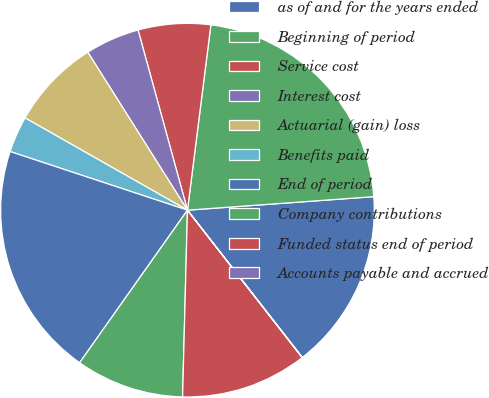Convert chart to OTSL. <chart><loc_0><loc_0><loc_500><loc_500><pie_chart><fcel>as of and for the years ended<fcel>Beginning of period<fcel>Service cost<fcel>Interest cost<fcel>Actuarial (gain) loss<fcel>Benefits paid<fcel>End of period<fcel>Company contributions<fcel>Funded status end of period<fcel>Accounts payable and accrued<nl><fcel>15.61%<fcel>21.85%<fcel>6.26%<fcel>4.7%<fcel>7.82%<fcel>3.14%<fcel>20.29%<fcel>9.38%<fcel>10.94%<fcel>0.02%<nl></chart> 